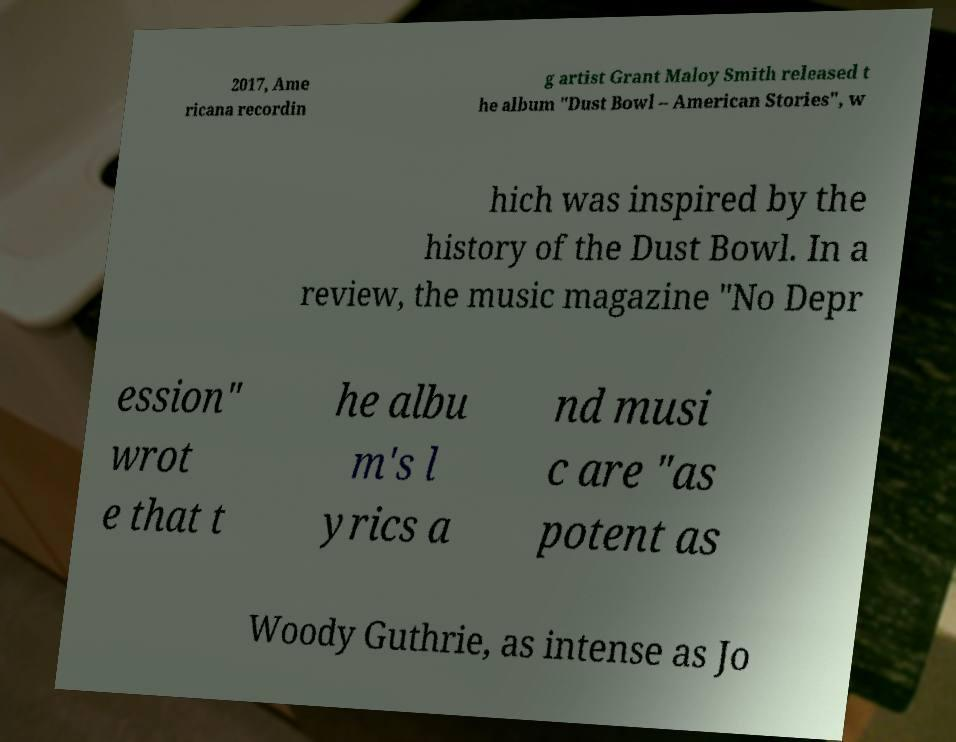Can you read and provide the text displayed in the image?This photo seems to have some interesting text. Can you extract and type it out for me? 2017, Ame ricana recordin g artist Grant Maloy Smith released t he album "Dust Bowl – American Stories", w hich was inspired by the history of the Dust Bowl. In a review, the music magazine "No Depr ession" wrot e that t he albu m's l yrics a nd musi c are "as potent as Woody Guthrie, as intense as Jo 